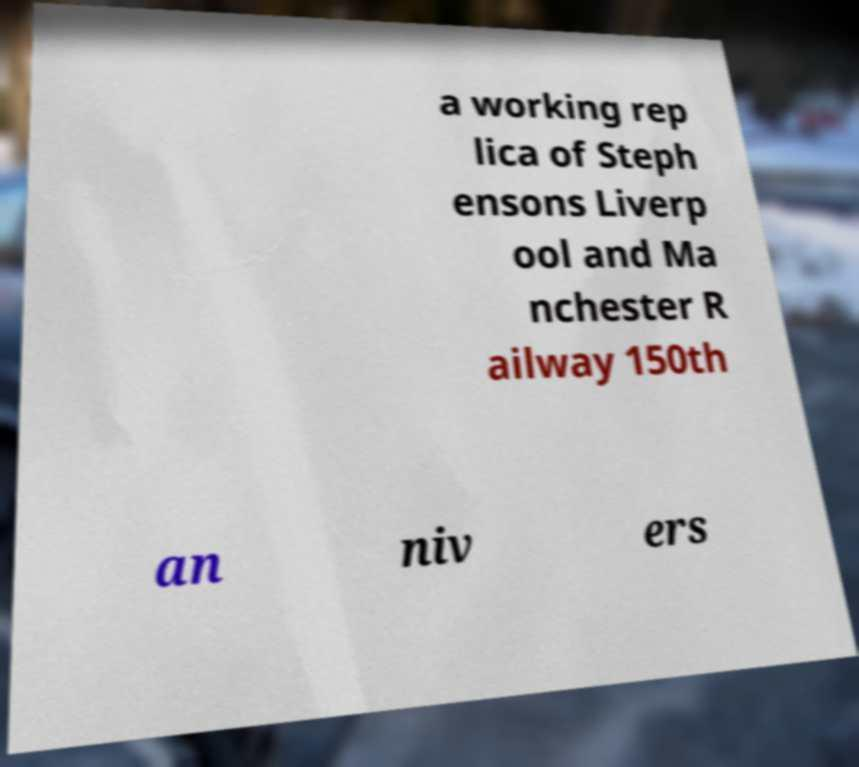Can you accurately transcribe the text from the provided image for me? a working rep lica of Steph ensons Liverp ool and Ma nchester R ailway 150th an niv ers 